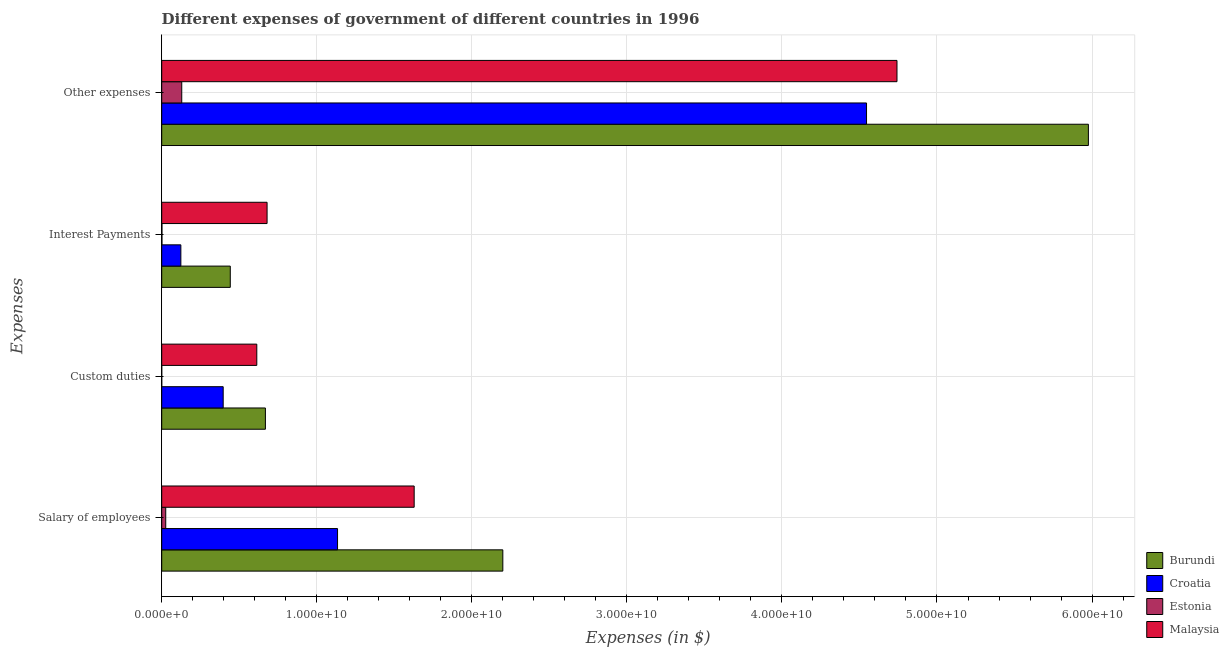How many different coloured bars are there?
Offer a terse response. 4. Are the number of bars per tick equal to the number of legend labels?
Offer a very short reply. Yes. What is the label of the 4th group of bars from the top?
Ensure brevity in your answer.  Salary of employees. What is the amount spent on salary of employees in Estonia?
Your answer should be compact. 2.59e+08. Across all countries, what is the maximum amount spent on custom duties?
Give a very brief answer. 6.69e+09. Across all countries, what is the minimum amount spent on other expenses?
Ensure brevity in your answer.  1.29e+09. In which country was the amount spent on custom duties maximum?
Your response must be concise. Burundi. In which country was the amount spent on other expenses minimum?
Give a very brief answer. Estonia. What is the total amount spent on salary of employees in the graph?
Your answer should be very brief. 4.99e+1. What is the difference between the amount spent on other expenses in Burundi and that in Malaysia?
Ensure brevity in your answer.  1.23e+1. What is the difference between the amount spent on salary of employees in Malaysia and the amount spent on other expenses in Burundi?
Your answer should be compact. -4.35e+1. What is the average amount spent on interest payments per country?
Offer a terse response. 3.12e+09. What is the difference between the amount spent on other expenses and amount spent on interest payments in Malaysia?
Your answer should be compact. 4.06e+1. In how many countries, is the amount spent on custom duties greater than 16000000000 $?
Offer a very short reply. 0. What is the ratio of the amount spent on interest payments in Burundi to that in Croatia?
Provide a succinct answer. 3.58. Is the amount spent on interest payments in Burundi less than that in Estonia?
Offer a very short reply. No. What is the difference between the highest and the second highest amount spent on custom duties?
Your answer should be very brief. 5.56e+08. What is the difference between the highest and the lowest amount spent on interest payments?
Your response must be concise. 6.78e+09. Is the sum of the amount spent on other expenses in Croatia and Burundi greater than the maximum amount spent on custom duties across all countries?
Ensure brevity in your answer.  Yes. What does the 1st bar from the top in Interest Payments represents?
Ensure brevity in your answer.  Malaysia. What does the 4th bar from the bottom in Salary of employees represents?
Provide a succinct answer. Malaysia. Does the graph contain any zero values?
Your answer should be very brief. No. What is the title of the graph?
Make the answer very short. Different expenses of government of different countries in 1996. What is the label or title of the X-axis?
Give a very brief answer. Expenses (in $). What is the label or title of the Y-axis?
Provide a short and direct response. Expenses. What is the Expenses (in $) of Burundi in Salary of employees?
Offer a terse response. 2.20e+1. What is the Expenses (in $) of Croatia in Salary of employees?
Provide a short and direct response. 1.13e+1. What is the Expenses (in $) of Estonia in Salary of employees?
Ensure brevity in your answer.  2.59e+08. What is the Expenses (in $) of Malaysia in Salary of employees?
Ensure brevity in your answer.  1.63e+1. What is the Expenses (in $) in Burundi in Custom duties?
Provide a short and direct response. 6.69e+09. What is the Expenses (in $) in Croatia in Custom duties?
Give a very brief answer. 3.96e+09. What is the Expenses (in $) of Estonia in Custom duties?
Provide a short and direct response. 3.00e+04. What is the Expenses (in $) of Malaysia in Custom duties?
Offer a terse response. 6.13e+09. What is the Expenses (in $) of Burundi in Interest Payments?
Provide a short and direct response. 4.42e+09. What is the Expenses (in $) in Croatia in Interest Payments?
Give a very brief answer. 1.23e+09. What is the Expenses (in $) of Estonia in Interest Payments?
Provide a succinct answer. 1.45e+07. What is the Expenses (in $) of Malaysia in Interest Payments?
Offer a terse response. 6.80e+09. What is the Expenses (in $) in Burundi in Other expenses?
Offer a terse response. 5.98e+1. What is the Expenses (in $) of Croatia in Other expenses?
Keep it short and to the point. 4.55e+1. What is the Expenses (in $) of Estonia in Other expenses?
Give a very brief answer. 1.29e+09. What is the Expenses (in $) of Malaysia in Other expenses?
Offer a very short reply. 4.74e+1. Across all Expenses, what is the maximum Expenses (in $) of Burundi?
Keep it short and to the point. 5.98e+1. Across all Expenses, what is the maximum Expenses (in $) of Croatia?
Offer a very short reply. 4.55e+1. Across all Expenses, what is the maximum Expenses (in $) of Estonia?
Offer a very short reply. 1.29e+09. Across all Expenses, what is the maximum Expenses (in $) in Malaysia?
Provide a short and direct response. 4.74e+1. Across all Expenses, what is the minimum Expenses (in $) of Burundi?
Ensure brevity in your answer.  4.42e+09. Across all Expenses, what is the minimum Expenses (in $) of Croatia?
Offer a very short reply. 1.23e+09. Across all Expenses, what is the minimum Expenses (in $) of Estonia?
Your answer should be compact. 3.00e+04. Across all Expenses, what is the minimum Expenses (in $) of Malaysia?
Provide a short and direct response. 6.13e+09. What is the total Expenses (in $) of Burundi in the graph?
Your answer should be very brief. 9.29e+1. What is the total Expenses (in $) of Croatia in the graph?
Give a very brief answer. 6.20e+1. What is the total Expenses (in $) in Estonia in the graph?
Provide a short and direct response. 1.57e+09. What is the total Expenses (in $) of Malaysia in the graph?
Offer a terse response. 7.66e+1. What is the difference between the Expenses (in $) of Burundi in Salary of employees and that in Custom duties?
Provide a succinct answer. 1.53e+1. What is the difference between the Expenses (in $) in Croatia in Salary of employees and that in Custom duties?
Your answer should be compact. 7.38e+09. What is the difference between the Expenses (in $) of Estonia in Salary of employees and that in Custom duties?
Make the answer very short. 2.59e+08. What is the difference between the Expenses (in $) in Malaysia in Salary of employees and that in Custom duties?
Provide a short and direct response. 1.02e+1. What is the difference between the Expenses (in $) of Burundi in Salary of employees and that in Interest Payments?
Provide a short and direct response. 1.76e+1. What is the difference between the Expenses (in $) in Croatia in Salary of employees and that in Interest Payments?
Your answer should be compact. 1.01e+1. What is the difference between the Expenses (in $) of Estonia in Salary of employees and that in Interest Payments?
Offer a terse response. 2.45e+08. What is the difference between the Expenses (in $) in Malaysia in Salary of employees and that in Interest Payments?
Your answer should be compact. 9.49e+09. What is the difference between the Expenses (in $) in Burundi in Salary of employees and that in Other expenses?
Your answer should be very brief. -3.78e+1. What is the difference between the Expenses (in $) of Croatia in Salary of employees and that in Other expenses?
Keep it short and to the point. -3.41e+1. What is the difference between the Expenses (in $) of Estonia in Salary of employees and that in Other expenses?
Your answer should be very brief. -1.03e+09. What is the difference between the Expenses (in $) of Malaysia in Salary of employees and that in Other expenses?
Your answer should be compact. -3.11e+1. What is the difference between the Expenses (in $) of Burundi in Custom duties and that in Interest Payments?
Offer a terse response. 2.27e+09. What is the difference between the Expenses (in $) of Croatia in Custom duties and that in Interest Payments?
Provide a succinct answer. 2.73e+09. What is the difference between the Expenses (in $) in Estonia in Custom duties and that in Interest Payments?
Give a very brief answer. -1.45e+07. What is the difference between the Expenses (in $) of Malaysia in Custom duties and that in Interest Payments?
Your answer should be very brief. -6.63e+08. What is the difference between the Expenses (in $) in Burundi in Custom duties and that in Other expenses?
Keep it short and to the point. -5.31e+1. What is the difference between the Expenses (in $) in Croatia in Custom duties and that in Other expenses?
Offer a very short reply. -4.15e+1. What is the difference between the Expenses (in $) of Estonia in Custom duties and that in Other expenses?
Provide a succinct answer. -1.29e+09. What is the difference between the Expenses (in $) of Malaysia in Custom duties and that in Other expenses?
Make the answer very short. -4.13e+1. What is the difference between the Expenses (in $) of Burundi in Interest Payments and that in Other expenses?
Your response must be concise. -5.53e+1. What is the difference between the Expenses (in $) in Croatia in Interest Payments and that in Other expenses?
Your answer should be compact. -4.42e+1. What is the difference between the Expenses (in $) in Estonia in Interest Payments and that in Other expenses?
Offer a terse response. -1.28e+09. What is the difference between the Expenses (in $) of Malaysia in Interest Payments and that in Other expenses?
Provide a short and direct response. -4.06e+1. What is the difference between the Expenses (in $) of Burundi in Salary of employees and the Expenses (in $) of Croatia in Custom duties?
Offer a terse response. 1.80e+1. What is the difference between the Expenses (in $) in Burundi in Salary of employees and the Expenses (in $) in Estonia in Custom duties?
Your response must be concise. 2.20e+1. What is the difference between the Expenses (in $) in Burundi in Salary of employees and the Expenses (in $) in Malaysia in Custom duties?
Give a very brief answer. 1.59e+1. What is the difference between the Expenses (in $) of Croatia in Salary of employees and the Expenses (in $) of Estonia in Custom duties?
Provide a succinct answer. 1.13e+1. What is the difference between the Expenses (in $) in Croatia in Salary of employees and the Expenses (in $) in Malaysia in Custom duties?
Your answer should be very brief. 5.21e+09. What is the difference between the Expenses (in $) of Estonia in Salary of employees and the Expenses (in $) of Malaysia in Custom duties?
Offer a terse response. -5.87e+09. What is the difference between the Expenses (in $) of Burundi in Salary of employees and the Expenses (in $) of Croatia in Interest Payments?
Your response must be concise. 2.08e+1. What is the difference between the Expenses (in $) of Burundi in Salary of employees and the Expenses (in $) of Estonia in Interest Payments?
Your answer should be very brief. 2.20e+1. What is the difference between the Expenses (in $) of Burundi in Salary of employees and the Expenses (in $) of Malaysia in Interest Payments?
Keep it short and to the point. 1.52e+1. What is the difference between the Expenses (in $) in Croatia in Salary of employees and the Expenses (in $) in Estonia in Interest Payments?
Give a very brief answer. 1.13e+1. What is the difference between the Expenses (in $) in Croatia in Salary of employees and the Expenses (in $) in Malaysia in Interest Payments?
Ensure brevity in your answer.  4.55e+09. What is the difference between the Expenses (in $) in Estonia in Salary of employees and the Expenses (in $) in Malaysia in Interest Payments?
Provide a succinct answer. -6.54e+09. What is the difference between the Expenses (in $) of Burundi in Salary of employees and the Expenses (in $) of Croatia in Other expenses?
Your answer should be very brief. -2.35e+1. What is the difference between the Expenses (in $) in Burundi in Salary of employees and the Expenses (in $) in Estonia in Other expenses?
Offer a very short reply. 2.07e+1. What is the difference between the Expenses (in $) of Burundi in Salary of employees and the Expenses (in $) of Malaysia in Other expenses?
Make the answer very short. -2.54e+1. What is the difference between the Expenses (in $) of Croatia in Salary of employees and the Expenses (in $) of Estonia in Other expenses?
Offer a terse response. 1.00e+1. What is the difference between the Expenses (in $) in Croatia in Salary of employees and the Expenses (in $) in Malaysia in Other expenses?
Offer a terse response. -3.61e+1. What is the difference between the Expenses (in $) in Estonia in Salary of employees and the Expenses (in $) in Malaysia in Other expenses?
Offer a terse response. -4.72e+1. What is the difference between the Expenses (in $) of Burundi in Custom duties and the Expenses (in $) of Croatia in Interest Payments?
Your answer should be very brief. 5.45e+09. What is the difference between the Expenses (in $) of Burundi in Custom duties and the Expenses (in $) of Estonia in Interest Payments?
Your answer should be compact. 6.67e+09. What is the difference between the Expenses (in $) in Burundi in Custom duties and the Expenses (in $) in Malaysia in Interest Payments?
Give a very brief answer. -1.07e+08. What is the difference between the Expenses (in $) in Croatia in Custom duties and the Expenses (in $) in Estonia in Interest Payments?
Your answer should be very brief. 3.95e+09. What is the difference between the Expenses (in $) in Croatia in Custom duties and the Expenses (in $) in Malaysia in Interest Payments?
Offer a very short reply. -2.83e+09. What is the difference between the Expenses (in $) of Estonia in Custom duties and the Expenses (in $) of Malaysia in Interest Payments?
Your answer should be very brief. -6.79e+09. What is the difference between the Expenses (in $) in Burundi in Custom duties and the Expenses (in $) in Croatia in Other expenses?
Keep it short and to the point. -3.88e+1. What is the difference between the Expenses (in $) of Burundi in Custom duties and the Expenses (in $) of Estonia in Other expenses?
Provide a succinct answer. 5.40e+09. What is the difference between the Expenses (in $) of Burundi in Custom duties and the Expenses (in $) of Malaysia in Other expenses?
Make the answer very short. -4.07e+1. What is the difference between the Expenses (in $) of Croatia in Custom duties and the Expenses (in $) of Estonia in Other expenses?
Your answer should be compact. 2.67e+09. What is the difference between the Expenses (in $) in Croatia in Custom duties and the Expenses (in $) in Malaysia in Other expenses?
Ensure brevity in your answer.  -4.35e+1. What is the difference between the Expenses (in $) of Estonia in Custom duties and the Expenses (in $) of Malaysia in Other expenses?
Ensure brevity in your answer.  -4.74e+1. What is the difference between the Expenses (in $) in Burundi in Interest Payments and the Expenses (in $) in Croatia in Other expenses?
Make the answer very short. -4.10e+1. What is the difference between the Expenses (in $) in Burundi in Interest Payments and the Expenses (in $) in Estonia in Other expenses?
Your answer should be compact. 3.13e+09. What is the difference between the Expenses (in $) in Burundi in Interest Payments and the Expenses (in $) in Malaysia in Other expenses?
Ensure brevity in your answer.  -4.30e+1. What is the difference between the Expenses (in $) in Croatia in Interest Payments and the Expenses (in $) in Estonia in Other expenses?
Make the answer very short. -5.81e+07. What is the difference between the Expenses (in $) in Croatia in Interest Payments and the Expenses (in $) in Malaysia in Other expenses?
Your answer should be very brief. -4.62e+1. What is the difference between the Expenses (in $) of Estonia in Interest Payments and the Expenses (in $) of Malaysia in Other expenses?
Your answer should be very brief. -4.74e+1. What is the average Expenses (in $) of Burundi per Expenses?
Offer a very short reply. 2.32e+1. What is the average Expenses (in $) of Croatia per Expenses?
Offer a terse response. 1.55e+1. What is the average Expenses (in $) in Estonia per Expenses?
Keep it short and to the point. 3.92e+08. What is the average Expenses (in $) in Malaysia per Expenses?
Keep it short and to the point. 1.92e+1. What is the difference between the Expenses (in $) in Burundi and Expenses (in $) in Croatia in Salary of employees?
Offer a terse response. 1.07e+1. What is the difference between the Expenses (in $) of Burundi and Expenses (in $) of Estonia in Salary of employees?
Your answer should be very brief. 2.17e+1. What is the difference between the Expenses (in $) of Burundi and Expenses (in $) of Malaysia in Salary of employees?
Make the answer very short. 5.72e+09. What is the difference between the Expenses (in $) of Croatia and Expenses (in $) of Estonia in Salary of employees?
Offer a terse response. 1.11e+1. What is the difference between the Expenses (in $) in Croatia and Expenses (in $) in Malaysia in Salary of employees?
Keep it short and to the point. -4.94e+09. What is the difference between the Expenses (in $) of Estonia and Expenses (in $) of Malaysia in Salary of employees?
Your answer should be compact. -1.60e+1. What is the difference between the Expenses (in $) of Burundi and Expenses (in $) of Croatia in Custom duties?
Give a very brief answer. 2.72e+09. What is the difference between the Expenses (in $) of Burundi and Expenses (in $) of Estonia in Custom duties?
Make the answer very short. 6.69e+09. What is the difference between the Expenses (in $) of Burundi and Expenses (in $) of Malaysia in Custom duties?
Ensure brevity in your answer.  5.56e+08. What is the difference between the Expenses (in $) in Croatia and Expenses (in $) in Estonia in Custom duties?
Your response must be concise. 3.96e+09. What is the difference between the Expenses (in $) in Croatia and Expenses (in $) in Malaysia in Custom duties?
Provide a short and direct response. -2.17e+09. What is the difference between the Expenses (in $) of Estonia and Expenses (in $) of Malaysia in Custom duties?
Your answer should be compact. -6.13e+09. What is the difference between the Expenses (in $) in Burundi and Expenses (in $) in Croatia in Interest Payments?
Your response must be concise. 3.19e+09. What is the difference between the Expenses (in $) of Burundi and Expenses (in $) of Estonia in Interest Payments?
Your answer should be very brief. 4.41e+09. What is the difference between the Expenses (in $) of Burundi and Expenses (in $) of Malaysia in Interest Payments?
Ensure brevity in your answer.  -2.37e+09. What is the difference between the Expenses (in $) in Croatia and Expenses (in $) in Estonia in Interest Payments?
Offer a terse response. 1.22e+09. What is the difference between the Expenses (in $) of Croatia and Expenses (in $) of Malaysia in Interest Payments?
Give a very brief answer. -5.56e+09. What is the difference between the Expenses (in $) of Estonia and Expenses (in $) of Malaysia in Interest Payments?
Keep it short and to the point. -6.78e+09. What is the difference between the Expenses (in $) in Burundi and Expenses (in $) in Croatia in Other expenses?
Offer a terse response. 1.43e+1. What is the difference between the Expenses (in $) of Burundi and Expenses (in $) of Estonia in Other expenses?
Offer a terse response. 5.85e+1. What is the difference between the Expenses (in $) in Burundi and Expenses (in $) in Malaysia in Other expenses?
Give a very brief answer. 1.23e+1. What is the difference between the Expenses (in $) in Croatia and Expenses (in $) in Estonia in Other expenses?
Provide a short and direct response. 4.42e+1. What is the difference between the Expenses (in $) in Croatia and Expenses (in $) in Malaysia in Other expenses?
Your response must be concise. -1.96e+09. What is the difference between the Expenses (in $) in Estonia and Expenses (in $) in Malaysia in Other expenses?
Offer a terse response. -4.61e+1. What is the ratio of the Expenses (in $) in Burundi in Salary of employees to that in Custom duties?
Give a very brief answer. 3.29. What is the ratio of the Expenses (in $) in Croatia in Salary of employees to that in Custom duties?
Give a very brief answer. 2.86. What is the ratio of the Expenses (in $) in Estonia in Salary of employees to that in Custom duties?
Your answer should be compact. 8640. What is the ratio of the Expenses (in $) in Malaysia in Salary of employees to that in Custom duties?
Your answer should be very brief. 2.66. What is the ratio of the Expenses (in $) of Burundi in Salary of employees to that in Interest Payments?
Provide a short and direct response. 4.98. What is the ratio of the Expenses (in $) of Croatia in Salary of employees to that in Interest Payments?
Make the answer very short. 9.19. What is the ratio of the Expenses (in $) in Estonia in Salary of employees to that in Interest Payments?
Ensure brevity in your answer.  17.88. What is the ratio of the Expenses (in $) in Malaysia in Salary of employees to that in Interest Payments?
Provide a short and direct response. 2.4. What is the ratio of the Expenses (in $) of Burundi in Salary of employees to that in Other expenses?
Ensure brevity in your answer.  0.37. What is the ratio of the Expenses (in $) of Croatia in Salary of employees to that in Other expenses?
Offer a very short reply. 0.25. What is the ratio of the Expenses (in $) in Estonia in Salary of employees to that in Other expenses?
Provide a succinct answer. 0.2. What is the ratio of the Expenses (in $) in Malaysia in Salary of employees to that in Other expenses?
Provide a succinct answer. 0.34. What is the ratio of the Expenses (in $) in Burundi in Custom duties to that in Interest Payments?
Your answer should be compact. 1.51. What is the ratio of the Expenses (in $) in Croatia in Custom duties to that in Interest Payments?
Ensure brevity in your answer.  3.21. What is the ratio of the Expenses (in $) of Estonia in Custom duties to that in Interest Payments?
Provide a short and direct response. 0. What is the ratio of the Expenses (in $) in Malaysia in Custom duties to that in Interest Payments?
Provide a short and direct response. 0.9. What is the ratio of the Expenses (in $) in Burundi in Custom duties to that in Other expenses?
Give a very brief answer. 0.11. What is the ratio of the Expenses (in $) in Croatia in Custom duties to that in Other expenses?
Keep it short and to the point. 0.09. What is the ratio of the Expenses (in $) of Malaysia in Custom duties to that in Other expenses?
Provide a short and direct response. 0.13. What is the ratio of the Expenses (in $) of Burundi in Interest Payments to that in Other expenses?
Make the answer very short. 0.07. What is the ratio of the Expenses (in $) of Croatia in Interest Payments to that in Other expenses?
Offer a terse response. 0.03. What is the ratio of the Expenses (in $) in Estonia in Interest Payments to that in Other expenses?
Make the answer very short. 0.01. What is the ratio of the Expenses (in $) in Malaysia in Interest Payments to that in Other expenses?
Provide a succinct answer. 0.14. What is the difference between the highest and the second highest Expenses (in $) in Burundi?
Provide a succinct answer. 3.78e+1. What is the difference between the highest and the second highest Expenses (in $) of Croatia?
Offer a very short reply. 3.41e+1. What is the difference between the highest and the second highest Expenses (in $) in Estonia?
Offer a very short reply. 1.03e+09. What is the difference between the highest and the second highest Expenses (in $) of Malaysia?
Offer a very short reply. 3.11e+1. What is the difference between the highest and the lowest Expenses (in $) of Burundi?
Offer a very short reply. 5.53e+1. What is the difference between the highest and the lowest Expenses (in $) in Croatia?
Keep it short and to the point. 4.42e+1. What is the difference between the highest and the lowest Expenses (in $) of Estonia?
Keep it short and to the point. 1.29e+09. What is the difference between the highest and the lowest Expenses (in $) in Malaysia?
Offer a terse response. 4.13e+1. 